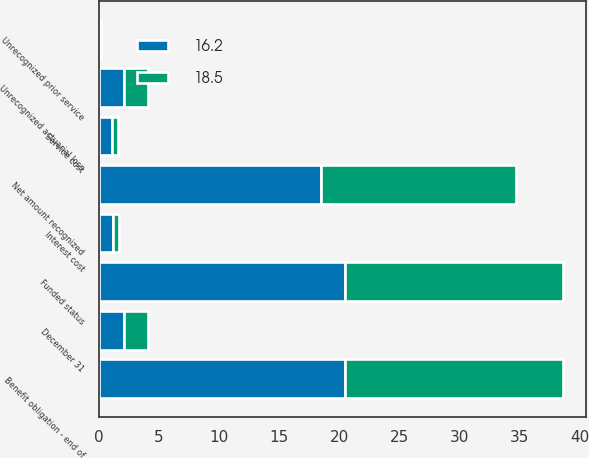Convert chart. <chart><loc_0><loc_0><loc_500><loc_500><stacked_bar_chart><ecel><fcel>December 31<fcel>Service cost<fcel>Interest cost<fcel>Benefit obligation - end of<fcel>Funded status<fcel>Unrecognized prior service<fcel>Unrecognized actuarial loss<fcel>Net amount recognized<nl><fcel>16.2<fcel>2.05<fcel>1.1<fcel>1.2<fcel>20.5<fcel>20.5<fcel>0.1<fcel>2.1<fcel>18.5<nl><fcel>18.5<fcel>2.05<fcel>0.5<fcel>0.5<fcel>18.1<fcel>18.1<fcel>0.1<fcel>2<fcel>16.2<nl></chart> 